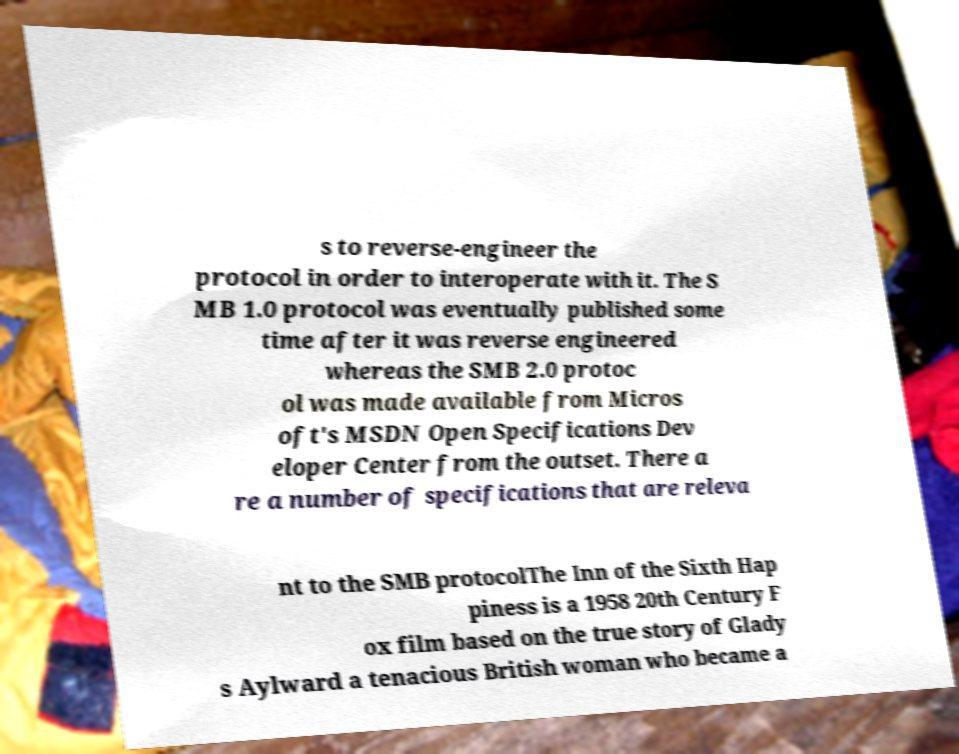What messages or text are displayed in this image? I need them in a readable, typed format. s to reverse-engineer the protocol in order to interoperate with it. The S MB 1.0 protocol was eventually published some time after it was reverse engineered whereas the SMB 2.0 protoc ol was made available from Micros oft's MSDN Open Specifications Dev eloper Center from the outset. There a re a number of specifications that are releva nt to the SMB protocolThe Inn of the Sixth Hap piness is a 1958 20th Century F ox film based on the true story of Glady s Aylward a tenacious British woman who became a 